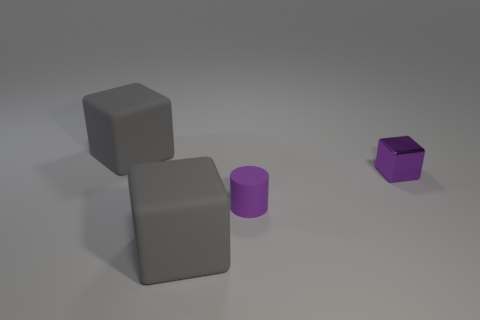Subtract all big gray matte cubes. How many cubes are left? 1 Subtract all cyan cylinders. How many gray blocks are left? 2 Add 1 small purple rubber cylinders. How many objects exist? 5 Subtract 1 blocks. How many blocks are left? 2 Subtract all cylinders. How many objects are left? 3 Subtract all cyan cubes. Subtract all blue cylinders. How many cubes are left? 3 Subtract all purple blocks. Subtract all large yellow shiny blocks. How many objects are left? 3 Add 1 purple shiny cubes. How many purple shiny cubes are left? 2 Add 2 big rubber blocks. How many big rubber blocks exist? 4 Subtract 0 cyan balls. How many objects are left? 4 